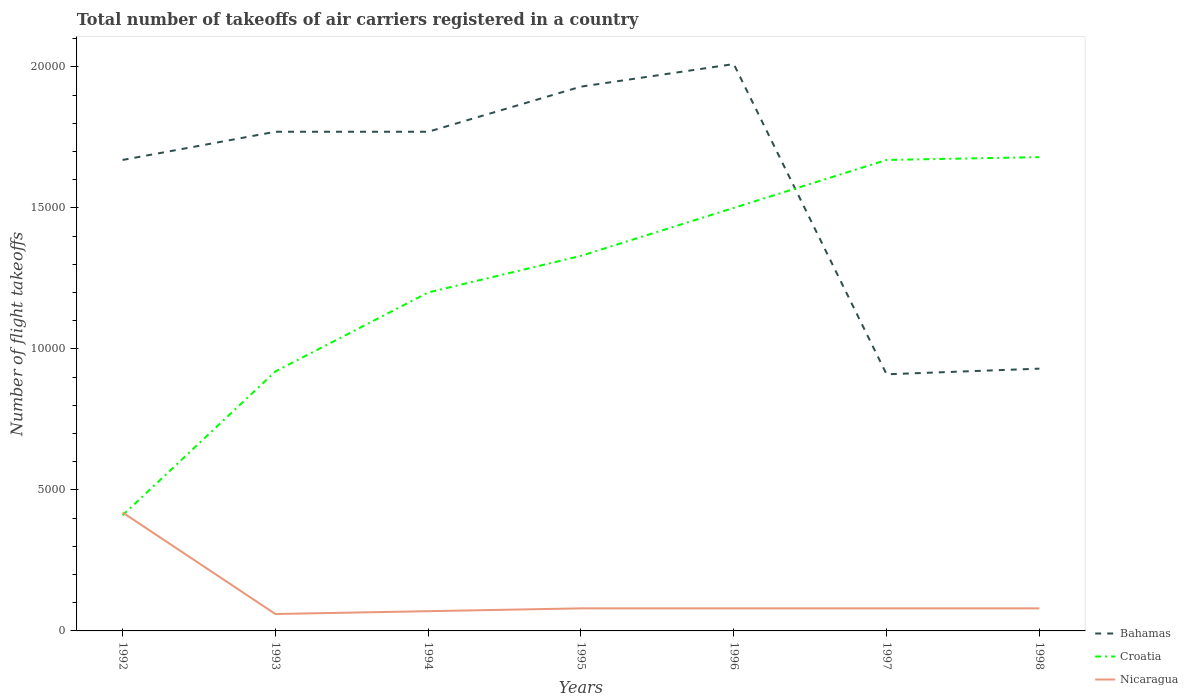Across all years, what is the maximum total number of flight takeoffs in Nicaragua?
Your answer should be compact. 600. In which year was the total number of flight takeoffs in Croatia maximum?
Offer a terse response. 1992. What is the total total number of flight takeoffs in Croatia in the graph?
Keep it short and to the point. -9200. What is the difference between the highest and the second highest total number of flight takeoffs in Nicaragua?
Ensure brevity in your answer.  3600. How many years are there in the graph?
Give a very brief answer. 7. Are the values on the major ticks of Y-axis written in scientific E-notation?
Your response must be concise. No. Does the graph contain grids?
Provide a short and direct response. No. Where does the legend appear in the graph?
Your answer should be compact. Bottom right. How are the legend labels stacked?
Make the answer very short. Vertical. What is the title of the graph?
Your response must be concise. Total number of takeoffs of air carriers registered in a country. Does "Uzbekistan" appear as one of the legend labels in the graph?
Your response must be concise. No. What is the label or title of the Y-axis?
Your response must be concise. Number of flight takeoffs. What is the Number of flight takeoffs in Bahamas in 1992?
Your answer should be very brief. 1.67e+04. What is the Number of flight takeoffs in Croatia in 1992?
Your answer should be very brief. 4100. What is the Number of flight takeoffs of Nicaragua in 1992?
Your answer should be very brief. 4200. What is the Number of flight takeoffs in Bahamas in 1993?
Provide a succinct answer. 1.77e+04. What is the Number of flight takeoffs in Croatia in 1993?
Make the answer very short. 9200. What is the Number of flight takeoffs of Nicaragua in 1993?
Make the answer very short. 600. What is the Number of flight takeoffs in Bahamas in 1994?
Provide a succinct answer. 1.77e+04. What is the Number of flight takeoffs in Croatia in 1994?
Your answer should be very brief. 1.20e+04. What is the Number of flight takeoffs in Nicaragua in 1994?
Your answer should be very brief. 700. What is the Number of flight takeoffs in Bahamas in 1995?
Provide a short and direct response. 1.93e+04. What is the Number of flight takeoffs in Croatia in 1995?
Provide a succinct answer. 1.33e+04. What is the Number of flight takeoffs in Nicaragua in 1995?
Make the answer very short. 800. What is the Number of flight takeoffs in Bahamas in 1996?
Provide a short and direct response. 2.01e+04. What is the Number of flight takeoffs in Croatia in 1996?
Give a very brief answer. 1.50e+04. What is the Number of flight takeoffs of Nicaragua in 1996?
Offer a terse response. 800. What is the Number of flight takeoffs in Bahamas in 1997?
Give a very brief answer. 9100. What is the Number of flight takeoffs of Croatia in 1997?
Keep it short and to the point. 1.67e+04. What is the Number of flight takeoffs in Nicaragua in 1997?
Your answer should be compact. 800. What is the Number of flight takeoffs in Bahamas in 1998?
Your response must be concise. 9300. What is the Number of flight takeoffs of Croatia in 1998?
Your answer should be very brief. 1.68e+04. What is the Number of flight takeoffs of Nicaragua in 1998?
Make the answer very short. 800. Across all years, what is the maximum Number of flight takeoffs of Bahamas?
Your answer should be compact. 2.01e+04. Across all years, what is the maximum Number of flight takeoffs of Croatia?
Offer a terse response. 1.68e+04. Across all years, what is the maximum Number of flight takeoffs in Nicaragua?
Make the answer very short. 4200. Across all years, what is the minimum Number of flight takeoffs in Bahamas?
Offer a very short reply. 9100. Across all years, what is the minimum Number of flight takeoffs of Croatia?
Offer a very short reply. 4100. Across all years, what is the minimum Number of flight takeoffs of Nicaragua?
Provide a succinct answer. 600. What is the total Number of flight takeoffs in Bahamas in the graph?
Keep it short and to the point. 1.10e+05. What is the total Number of flight takeoffs in Croatia in the graph?
Offer a terse response. 8.71e+04. What is the total Number of flight takeoffs in Nicaragua in the graph?
Make the answer very short. 8700. What is the difference between the Number of flight takeoffs in Bahamas in 1992 and that in 1993?
Offer a very short reply. -1000. What is the difference between the Number of flight takeoffs of Croatia in 1992 and that in 1993?
Make the answer very short. -5100. What is the difference between the Number of flight takeoffs of Nicaragua in 1992 and that in 1993?
Ensure brevity in your answer.  3600. What is the difference between the Number of flight takeoffs of Bahamas in 1992 and that in 1994?
Give a very brief answer. -1000. What is the difference between the Number of flight takeoffs in Croatia in 1992 and that in 1994?
Keep it short and to the point. -7900. What is the difference between the Number of flight takeoffs in Nicaragua in 1992 and that in 1994?
Keep it short and to the point. 3500. What is the difference between the Number of flight takeoffs in Bahamas in 1992 and that in 1995?
Keep it short and to the point. -2600. What is the difference between the Number of flight takeoffs of Croatia in 1992 and that in 1995?
Offer a very short reply. -9200. What is the difference between the Number of flight takeoffs in Nicaragua in 1992 and that in 1995?
Your answer should be compact. 3400. What is the difference between the Number of flight takeoffs of Bahamas in 1992 and that in 1996?
Offer a very short reply. -3400. What is the difference between the Number of flight takeoffs of Croatia in 1992 and that in 1996?
Your answer should be very brief. -1.09e+04. What is the difference between the Number of flight takeoffs of Nicaragua in 1992 and that in 1996?
Offer a very short reply. 3400. What is the difference between the Number of flight takeoffs of Bahamas in 1992 and that in 1997?
Provide a succinct answer. 7600. What is the difference between the Number of flight takeoffs in Croatia in 1992 and that in 1997?
Make the answer very short. -1.26e+04. What is the difference between the Number of flight takeoffs of Nicaragua in 1992 and that in 1997?
Make the answer very short. 3400. What is the difference between the Number of flight takeoffs of Bahamas in 1992 and that in 1998?
Give a very brief answer. 7400. What is the difference between the Number of flight takeoffs in Croatia in 1992 and that in 1998?
Your response must be concise. -1.27e+04. What is the difference between the Number of flight takeoffs of Nicaragua in 1992 and that in 1998?
Provide a succinct answer. 3400. What is the difference between the Number of flight takeoffs of Croatia in 1993 and that in 1994?
Offer a very short reply. -2800. What is the difference between the Number of flight takeoffs of Nicaragua in 1993 and that in 1994?
Offer a terse response. -100. What is the difference between the Number of flight takeoffs of Bahamas in 1993 and that in 1995?
Your answer should be very brief. -1600. What is the difference between the Number of flight takeoffs of Croatia in 1993 and that in 1995?
Your answer should be compact. -4100. What is the difference between the Number of flight takeoffs in Nicaragua in 1993 and that in 1995?
Offer a very short reply. -200. What is the difference between the Number of flight takeoffs in Bahamas in 1993 and that in 1996?
Offer a terse response. -2400. What is the difference between the Number of flight takeoffs of Croatia in 1993 and that in 1996?
Provide a succinct answer. -5800. What is the difference between the Number of flight takeoffs in Nicaragua in 1993 and that in 1996?
Your answer should be compact. -200. What is the difference between the Number of flight takeoffs of Bahamas in 1993 and that in 1997?
Your response must be concise. 8600. What is the difference between the Number of flight takeoffs of Croatia in 1993 and that in 1997?
Your response must be concise. -7500. What is the difference between the Number of flight takeoffs in Nicaragua in 1993 and that in 1997?
Make the answer very short. -200. What is the difference between the Number of flight takeoffs in Bahamas in 1993 and that in 1998?
Offer a very short reply. 8400. What is the difference between the Number of flight takeoffs in Croatia in 1993 and that in 1998?
Provide a succinct answer. -7600. What is the difference between the Number of flight takeoffs of Nicaragua in 1993 and that in 1998?
Your answer should be very brief. -200. What is the difference between the Number of flight takeoffs of Bahamas in 1994 and that in 1995?
Give a very brief answer. -1600. What is the difference between the Number of flight takeoffs of Croatia in 1994 and that in 1995?
Offer a terse response. -1300. What is the difference between the Number of flight takeoffs of Nicaragua in 1994 and that in 1995?
Keep it short and to the point. -100. What is the difference between the Number of flight takeoffs in Bahamas in 1994 and that in 1996?
Give a very brief answer. -2400. What is the difference between the Number of flight takeoffs of Croatia in 1994 and that in 1996?
Your answer should be very brief. -3000. What is the difference between the Number of flight takeoffs of Nicaragua in 1994 and that in 1996?
Offer a terse response. -100. What is the difference between the Number of flight takeoffs in Bahamas in 1994 and that in 1997?
Offer a terse response. 8600. What is the difference between the Number of flight takeoffs in Croatia in 1994 and that in 1997?
Provide a short and direct response. -4700. What is the difference between the Number of flight takeoffs of Nicaragua in 1994 and that in 1997?
Provide a short and direct response. -100. What is the difference between the Number of flight takeoffs of Bahamas in 1994 and that in 1998?
Your response must be concise. 8400. What is the difference between the Number of flight takeoffs in Croatia in 1994 and that in 1998?
Your response must be concise. -4800. What is the difference between the Number of flight takeoffs in Nicaragua in 1994 and that in 1998?
Your response must be concise. -100. What is the difference between the Number of flight takeoffs in Bahamas in 1995 and that in 1996?
Ensure brevity in your answer.  -800. What is the difference between the Number of flight takeoffs in Croatia in 1995 and that in 1996?
Provide a short and direct response. -1700. What is the difference between the Number of flight takeoffs in Nicaragua in 1995 and that in 1996?
Provide a succinct answer. 0. What is the difference between the Number of flight takeoffs of Bahamas in 1995 and that in 1997?
Keep it short and to the point. 1.02e+04. What is the difference between the Number of flight takeoffs in Croatia in 1995 and that in 1997?
Give a very brief answer. -3400. What is the difference between the Number of flight takeoffs of Bahamas in 1995 and that in 1998?
Your response must be concise. 10000. What is the difference between the Number of flight takeoffs in Croatia in 1995 and that in 1998?
Give a very brief answer. -3500. What is the difference between the Number of flight takeoffs in Bahamas in 1996 and that in 1997?
Keep it short and to the point. 1.10e+04. What is the difference between the Number of flight takeoffs of Croatia in 1996 and that in 1997?
Your answer should be compact. -1700. What is the difference between the Number of flight takeoffs in Bahamas in 1996 and that in 1998?
Offer a terse response. 1.08e+04. What is the difference between the Number of flight takeoffs in Croatia in 1996 and that in 1998?
Ensure brevity in your answer.  -1800. What is the difference between the Number of flight takeoffs in Bahamas in 1997 and that in 1998?
Provide a short and direct response. -200. What is the difference between the Number of flight takeoffs in Croatia in 1997 and that in 1998?
Make the answer very short. -100. What is the difference between the Number of flight takeoffs in Bahamas in 1992 and the Number of flight takeoffs in Croatia in 1993?
Your response must be concise. 7500. What is the difference between the Number of flight takeoffs of Bahamas in 1992 and the Number of flight takeoffs of Nicaragua in 1993?
Give a very brief answer. 1.61e+04. What is the difference between the Number of flight takeoffs in Croatia in 1992 and the Number of flight takeoffs in Nicaragua in 1993?
Your response must be concise. 3500. What is the difference between the Number of flight takeoffs of Bahamas in 1992 and the Number of flight takeoffs of Croatia in 1994?
Make the answer very short. 4700. What is the difference between the Number of flight takeoffs of Bahamas in 1992 and the Number of flight takeoffs of Nicaragua in 1994?
Your response must be concise. 1.60e+04. What is the difference between the Number of flight takeoffs in Croatia in 1992 and the Number of flight takeoffs in Nicaragua in 1994?
Give a very brief answer. 3400. What is the difference between the Number of flight takeoffs of Bahamas in 1992 and the Number of flight takeoffs of Croatia in 1995?
Ensure brevity in your answer.  3400. What is the difference between the Number of flight takeoffs in Bahamas in 1992 and the Number of flight takeoffs in Nicaragua in 1995?
Your answer should be very brief. 1.59e+04. What is the difference between the Number of flight takeoffs in Croatia in 1992 and the Number of flight takeoffs in Nicaragua in 1995?
Keep it short and to the point. 3300. What is the difference between the Number of flight takeoffs in Bahamas in 1992 and the Number of flight takeoffs in Croatia in 1996?
Ensure brevity in your answer.  1700. What is the difference between the Number of flight takeoffs of Bahamas in 1992 and the Number of flight takeoffs of Nicaragua in 1996?
Give a very brief answer. 1.59e+04. What is the difference between the Number of flight takeoffs of Croatia in 1992 and the Number of flight takeoffs of Nicaragua in 1996?
Your answer should be very brief. 3300. What is the difference between the Number of flight takeoffs in Bahamas in 1992 and the Number of flight takeoffs in Nicaragua in 1997?
Make the answer very short. 1.59e+04. What is the difference between the Number of flight takeoffs in Croatia in 1992 and the Number of flight takeoffs in Nicaragua in 1997?
Give a very brief answer. 3300. What is the difference between the Number of flight takeoffs of Bahamas in 1992 and the Number of flight takeoffs of Croatia in 1998?
Offer a very short reply. -100. What is the difference between the Number of flight takeoffs in Bahamas in 1992 and the Number of flight takeoffs in Nicaragua in 1998?
Give a very brief answer. 1.59e+04. What is the difference between the Number of flight takeoffs in Croatia in 1992 and the Number of flight takeoffs in Nicaragua in 1998?
Offer a very short reply. 3300. What is the difference between the Number of flight takeoffs in Bahamas in 1993 and the Number of flight takeoffs in Croatia in 1994?
Make the answer very short. 5700. What is the difference between the Number of flight takeoffs of Bahamas in 1993 and the Number of flight takeoffs of Nicaragua in 1994?
Your answer should be compact. 1.70e+04. What is the difference between the Number of flight takeoffs in Croatia in 1993 and the Number of flight takeoffs in Nicaragua in 1994?
Make the answer very short. 8500. What is the difference between the Number of flight takeoffs in Bahamas in 1993 and the Number of flight takeoffs in Croatia in 1995?
Give a very brief answer. 4400. What is the difference between the Number of flight takeoffs in Bahamas in 1993 and the Number of flight takeoffs in Nicaragua in 1995?
Your answer should be very brief. 1.69e+04. What is the difference between the Number of flight takeoffs in Croatia in 1993 and the Number of flight takeoffs in Nicaragua in 1995?
Provide a short and direct response. 8400. What is the difference between the Number of flight takeoffs in Bahamas in 1993 and the Number of flight takeoffs in Croatia in 1996?
Keep it short and to the point. 2700. What is the difference between the Number of flight takeoffs in Bahamas in 1993 and the Number of flight takeoffs in Nicaragua in 1996?
Offer a very short reply. 1.69e+04. What is the difference between the Number of flight takeoffs of Croatia in 1993 and the Number of flight takeoffs of Nicaragua in 1996?
Offer a very short reply. 8400. What is the difference between the Number of flight takeoffs in Bahamas in 1993 and the Number of flight takeoffs in Croatia in 1997?
Provide a short and direct response. 1000. What is the difference between the Number of flight takeoffs in Bahamas in 1993 and the Number of flight takeoffs in Nicaragua in 1997?
Offer a very short reply. 1.69e+04. What is the difference between the Number of flight takeoffs in Croatia in 1993 and the Number of flight takeoffs in Nicaragua in 1997?
Offer a very short reply. 8400. What is the difference between the Number of flight takeoffs of Bahamas in 1993 and the Number of flight takeoffs of Croatia in 1998?
Ensure brevity in your answer.  900. What is the difference between the Number of flight takeoffs in Bahamas in 1993 and the Number of flight takeoffs in Nicaragua in 1998?
Offer a terse response. 1.69e+04. What is the difference between the Number of flight takeoffs in Croatia in 1993 and the Number of flight takeoffs in Nicaragua in 1998?
Provide a short and direct response. 8400. What is the difference between the Number of flight takeoffs in Bahamas in 1994 and the Number of flight takeoffs in Croatia in 1995?
Ensure brevity in your answer.  4400. What is the difference between the Number of flight takeoffs in Bahamas in 1994 and the Number of flight takeoffs in Nicaragua in 1995?
Provide a short and direct response. 1.69e+04. What is the difference between the Number of flight takeoffs of Croatia in 1994 and the Number of flight takeoffs of Nicaragua in 1995?
Make the answer very short. 1.12e+04. What is the difference between the Number of flight takeoffs of Bahamas in 1994 and the Number of flight takeoffs of Croatia in 1996?
Your answer should be very brief. 2700. What is the difference between the Number of flight takeoffs in Bahamas in 1994 and the Number of flight takeoffs in Nicaragua in 1996?
Your answer should be very brief. 1.69e+04. What is the difference between the Number of flight takeoffs of Croatia in 1994 and the Number of flight takeoffs of Nicaragua in 1996?
Provide a short and direct response. 1.12e+04. What is the difference between the Number of flight takeoffs in Bahamas in 1994 and the Number of flight takeoffs in Croatia in 1997?
Your response must be concise. 1000. What is the difference between the Number of flight takeoffs in Bahamas in 1994 and the Number of flight takeoffs in Nicaragua in 1997?
Your response must be concise. 1.69e+04. What is the difference between the Number of flight takeoffs in Croatia in 1994 and the Number of flight takeoffs in Nicaragua in 1997?
Offer a terse response. 1.12e+04. What is the difference between the Number of flight takeoffs in Bahamas in 1994 and the Number of flight takeoffs in Croatia in 1998?
Offer a terse response. 900. What is the difference between the Number of flight takeoffs of Bahamas in 1994 and the Number of flight takeoffs of Nicaragua in 1998?
Provide a succinct answer. 1.69e+04. What is the difference between the Number of flight takeoffs in Croatia in 1994 and the Number of flight takeoffs in Nicaragua in 1998?
Keep it short and to the point. 1.12e+04. What is the difference between the Number of flight takeoffs of Bahamas in 1995 and the Number of flight takeoffs of Croatia in 1996?
Provide a short and direct response. 4300. What is the difference between the Number of flight takeoffs in Bahamas in 1995 and the Number of flight takeoffs in Nicaragua in 1996?
Ensure brevity in your answer.  1.85e+04. What is the difference between the Number of flight takeoffs in Croatia in 1995 and the Number of flight takeoffs in Nicaragua in 1996?
Your answer should be very brief. 1.25e+04. What is the difference between the Number of flight takeoffs in Bahamas in 1995 and the Number of flight takeoffs in Croatia in 1997?
Your answer should be compact. 2600. What is the difference between the Number of flight takeoffs of Bahamas in 1995 and the Number of flight takeoffs of Nicaragua in 1997?
Ensure brevity in your answer.  1.85e+04. What is the difference between the Number of flight takeoffs in Croatia in 1995 and the Number of flight takeoffs in Nicaragua in 1997?
Offer a terse response. 1.25e+04. What is the difference between the Number of flight takeoffs of Bahamas in 1995 and the Number of flight takeoffs of Croatia in 1998?
Provide a succinct answer. 2500. What is the difference between the Number of flight takeoffs in Bahamas in 1995 and the Number of flight takeoffs in Nicaragua in 1998?
Your answer should be compact. 1.85e+04. What is the difference between the Number of flight takeoffs in Croatia in 1995 and the Number of flight takeoffs in Nicaragua in 1998?
Your answer should be compact. 1.25e+04. What is the difference between the Number of flight takeoffs in Bahamas in 1996 and the Number of flight takeoffs in Croatia in 1997?
Your answer should be compact. 3400. What is the difference between the Number of flight takeoffs of Bahamas in 1996 and the Number of flight takeoffs of Nicaragua in 1997?
Provide a short and direct response. 1.93e+04. What is the difference between the Number of flight takeoffs in Croatia in 1996 and the Number of flight takeoffs in Nicaragua in 1997?
Your response must be concise. 1.42e+04. What is the difference between the Number of flight takeoffs of Bahamas in 1996 and the Number of flight takeoffs of Croatia in 1998?
Make the answer very short. 3300. What is the difference between the Number of flight takeoffs of Bahamas in 1996 and the Number of flight takeoffs of Nicaragua in 1998?
Keep it short and to the point. 1.93e+04. What is the difference between the Number of flight takeoffs in Croatia in 1996 and the Number of flight takeoffs in Nicaragua in 1998?
Your response must be concise. 1.42e+04. What is the difference between the Number of flight takeoffs in Bahamas in 1997 and the Number of flight takeoffs in Croatia in 1998?
Give a very brief answer. -7700. What is the difference between the Number of flight takeoffs of Bahamas in 1997 and the Number of flight takeoffs of Nicaragua in 1998?
Your answer should be compact. 8300. What is the difference between the Number of flight takeoffs of Croatia in 1997 and the Number of flight takeoffs of Nicaragua in 1998?
Offer a terse response. 1.59e+04. What is the average Number of flight takeoffs of Bahamas per year?
Give a very brief answer. 1.57e+04. What is the average Number of flight takeoffs in Croatia per year?
Your answer should be compact. 1.24e+04. What is the average Number of flight takeoffs of Nicaragua per year?
Give a very brief answer. 1242.86. In the year 1992, what is the difference between the Number of flight takeoffs of Bahamas and Number of flight takeoffs of Croatia?
Your answer should be compact. 1.26e+04. In the year 1992, what is the difference between the Number of flight takeoffs in Bahamas and Number of flight takeoffs in Nicaragua?
Your answer should be very brief. 1.25e+04. In the year 1992, what is the difference between the Number of flight takeoffs of Croatia and Number of flight takeoffs of Nicaragua?
Make the answer very short. -100. In the year 1993, what is the difference between the Number of flight takeoffs of Bahamas and Number of flight takeoffs of Croatia?
Provide a succinct answer. 8500. In the year 1993, what is the difference between the Number of flight takeoffs in Bahamas and Number of flight takeoffs in Nicaragua?
Make the answer very short. 1.71e+04. In the year 1993, what is the difference between the Number of flight takeoffs of Croatia and Number of flight takeoffs of Nicaragua?
Your answer should be very brief. 8600. In the year 1994, what is the difference between the Number of flight takeoffs in Bahamas and Number of flight takeoffs in Croatia?
Keep it short and to the point. 5700. In the year 1994, what is the difference between the Number of flight takeoffs in Bahamas and Number of flight takeoffs in Nicaragua?
Provide a short and direct response. 1.70e+04. In the year 1994, what is the difference between the Number of flight takeoffs of Croatia and Number of flight takeoffs of Nicaragua?
Provide a succinct answer. 1.13e+04. In the year 1995, what is the difference between the Number of flight takeoffs in Bahamas and Number of flight takeoffs in Croatia?
Ensure brevity in your answer.  6000. In the year 1995, what is the difference between the Number of flight takeoffs in Bahamas and Number of flight takeoffs in Nicaragua?
Your response must be concise. 1.85e+04. In the year 1995, what is the difference between the Number of flight takeoffs of Croatia and Number of flight takeoffs of Nicaragua?
Offer a terse response. 1.25e+04. In the year 1996, what is the difference between the Number of flight takeoffs of Bahamas and Number of flight takeoffs of Croatia?
Offer a very short reply. 5100. In the year 1996, what is the difference between the Number of flight takeoffs in Bahamas and Number of flight takeoffs in Nicaragua?
Offer a very short reply. 1.93e+04. In the year 1996, what is the difference between the Number of flight takeoffs in Croatia and Number of flight takeoffs in Nicaragua?
Provide a succinct answer. 1.42e+04. In the year 1997, what is the difference between the Number of flight takeoffs in Bahamas and Number of flight takeoffs in Croatia?
Make the answer very short. -7600. In the year 1997, what is the difference between the Number of flight takeoffs of Bahamas and Number of flight takeoffs of Nicaragua?
Provide a succinct answer. 8300. In the year 1997, what is the difference between the Number of flight takeoffs of Croatia and Number of flight takeoffs of Nicaragua?
Give a very brief answer. 1.59e+04. In the year 1998, what is the difference between the Number of flight takeoffs in Bahamas and Number of flight takeoffs in Croatia?
Provide a short and direct response. -7500. In the year 1998, what is the difference between the Number of flight takeoffs in Bahamas and Number of flight takeoffs in Nicaragua?
Ensure brevity in your answer.  8500. In the year 1998, what is the difference between the Number of flight takeoffs in Croatia and Number of flight takeoffs in Nicaragua?
Your response must be concise. 1.60e+04. What is the ratio of the Number of flight takeoffs in Bahamas in 1992 to that in 1993?
Offer a very short reply. 0.94. What is the ratio of the Number of flight takeoffs of Croatia in 1992 to that in 1993?
Your response must be concise. 0.45. What is the ratio of the Number of flight takeoffs in Nicaragua in 1992 to that in 1993?
Offer a very short reply. 7. What is the ratio of the Number of flight takeoffs in Bahamas in 1992 to that in 1994?
Provide a short and direct response. 0.94. What is the ratio of the Number of flight takeoffs in Croatia in 1992 to that in 1994?
Ensure brevity in your answer.  0.34. What is the ratio of the Number of flight takeoffs in Bahamas in 1992 to that in 1995?
Ensure brevity in your answer.  0.87. What is the ratio of the Number of flight takeoffs in Croatia in 1992 to that in 1995?
Your answer should be very brief. 0.31. What is the ratio of the Number of flight takeoffs of Nicaragua in 1992 to that in 1995?
Keep it short and to the point. 5.25. What is the ratio of the Number of flight takeoffs in Bahamas in 1992 to that in 1996?
Your response must be concise. 0.83. What is the ratio of the Number of flight takeoffs of Croatia in 1992 to that in 1996?
Offer a very short reply. 0.27. What is the ratio of the Number of flight takeoffs in Nicaragua in 1992 to that in 1996?
Your answer should be compact. 5.25. What is the ratio of the Number of flight takeoffs of Bahamas in 1992 to that in 1997?
Your answer should be very brief. 1.84. What is the ratio of the Number of flight takeoffs of Croatia in 1992 to that in 1997?
Give a very brief answer. 0.25. What is the ratio of the Number of flight takeoffs in Nicaragua in 1992 to that in 1997?
Ensure brevity in your answer.  5.25. What is the ratio of the Number of flight takeoffs in Bahamas in 1992 to that in 1998?
Make the answer very short. 1.8. What is the ratio of the Number of flight takeoffs of Croatia in 1992 to that in 1998?
Keep it short and to the point. 0.24. What is the ratio of the Number of flight takeoffs of Nicaragua in 1992 to that in 1998?
Your response must be concise. 5.25. What is the ratio of the Number of flight takeoffs of Bahamas in 1993 to that in 1994?
Your answer should be compact. 1. What is the ratio of the Number of flight takeoffs in Croatia in 1993 to that in 1994?
Ensure brevity in your answer.  0.77. What is the ratio of the Number of flight takeoffs of Nicaragua in 1993 to that in 1994?
Offer a very short reply. 0.86. What is the ratio of the Number of flight takeoffs in Bahamas in 1993 to that in 1995?
Your answer should be very brief. 0.92. What is the ratio of the Number of flight takeoffs in Croatia in 1993 to that in 1995?
Provide a short and direct response. 0.69. What is the ratio of the Number of flight takeoffs of Nicaragua in 1993 to that in 1995?
Offer a terse response. 0.75. What is the ratio of the Number of flight takeoffs in Bahamas in 1993 to that in 1996?
Offer a terse response. 0.88. What is the ratio of the Number of flight takeoffs of Croatia in 1993 to that in 1996?
Offer a terse response. 0.61. What is the ratio of the Number of flight takeoffs in Nicaragua in 1993 to that in 1996?
Provide a succinct answer. 0.75. What is the ratio of the Number of flight takeoffs in Bahamas in 1993 to that in 1997?
Your answer should be compact. 1.95. What is the ratio of the Number of flight takeoffs of Croatia in 1993 to that in 1997?
Keep it short and to the point. 0.55. What is the ratio of the Number of flight takeoffs in Bahamas in 1993 to that in 1998?
Offer a terse response. 1.9. What is the ratio of the Number of flight takeoffs of Croatia in 1993 to that in 1998?
Your answer should be very brief. 0.55. What is the ratio of the Number of flight takeoffs of Nicaragua in 1993 to that in 1998?
Offer a terse response. 0.75. What is the ratio of the Number of flight takeoffs of Bahamas in 1994 to that in 1995?
Make the answer very short. 0.92. What is the ratio of the Number of flight takeoffs of Croatia in 1994 to that in 1995?
Keep it short and to the point. 0.9. What is the ratio of the Number of flight takeoffs of Nicaragua in 1994 to that in 1995?
Offer a very short reply. 0.88. What is the ratio of the Number of flight takeoffs of Bahamas in 1994 to that in 1996?
Give a very brief answer. 0.88. What is the ratio of the Number of flight takeoffs in Bahamas in 1994 to that in 1997?
Give a very brief answer. 1.95. What is the ratio of the Number of flight takeoffs of Croatia in 1994 to that in 1997?
Offer a very short reply. 0.72. What is the ratio of the Number of flight takeoffs in Nicaragua in 1994 to that in 1997?
Give a very brief answer. 0.88. What is the ratio of the Number of flight takeoffs in Bahamas in 1994 to that in 1998?
Your answer should be very brief. 1.9. What is the ratio of the Number of flight takeoffs of Croatia in 1994 to that in 1998?
Provide a succinct answer. 0.71. What is the ratio of the Number of flight takeoffs in Nicaragua in 1994 to that in 1998?
Your response must be concise. 0.88. What is the ratio of the Number of flight takeoffs in Bahamas in 1995 to that in 1996?
Provide a short and direct response. 0.96. What is the ratio of the Number of flight takeoffs in Croatia in 1995 to that in 1996?
Make the answer very short. 0.89. What is the ratio of the Number of flight takeoffs of Bahamas in 1995 to that in 1997?
Provide a short and direct response. 2.12. What is the ratio of the Number of flight takeoffs of Croatia in 1995 to that in 1997?
Ensure brevity in your answer.  0.8. What is the ratio of the Number of flight takeoffs in Nicaragua in 1995 to that in 1997?
Ensure brevity in your answer.  1. What is the ratio of the Number of flight takeoffs of Bahamas in 1995 to that in 1998?
Ensure brevity in your answer.  2.08. What is the ratio of the Number of flight takeoffs in Croatia in 1995 to that in 1998?
Your answer should be very brief. 0.79. What is the ratio of the Number of flight takeoffs in Bahamas in 1996 to that in 1997?
Provide a succinct answer. 2.21. What is the ratio of the Number of flight takeoffs of Croatia in 1996 to that in 1997?
Offer a very short reply. 0.9. What is the ratio of the Number of flight takeoffs in Bahamas in 1996 to that in 1998?
Offer a very short reply. 2.16. What is the ratio of the Number of flight takeoffs in Croatia in 1996 to that in 1998?
Provide a short and direct response. 0.89. What is the ratio of the Number of flight takeoffs in Bahamas in 1997 to that in 1998?
Offer a terse response. 0.98. What is the difference between the highest and the second highest Number of flight takeoffs in Bahamas?
Your answer should be very brief. 800. What is the difference between the highest and the second highest Number of flight takeoffs of Nicaragua?
Offer a terse response. 3400. What is the difference between the highest and the lowest Number of flight takeoffs in Bahamas?
Offer a terse response. 1.10e+04. What is the difference between the highest and the lowest Number of flight takeoffs in Croatia?
Offer a very short reply. 1.27e+04. What is the difference between the highest and the lowest Number of flight takeoffs of Nicaragua?
Offer a very short reply. 3600. 